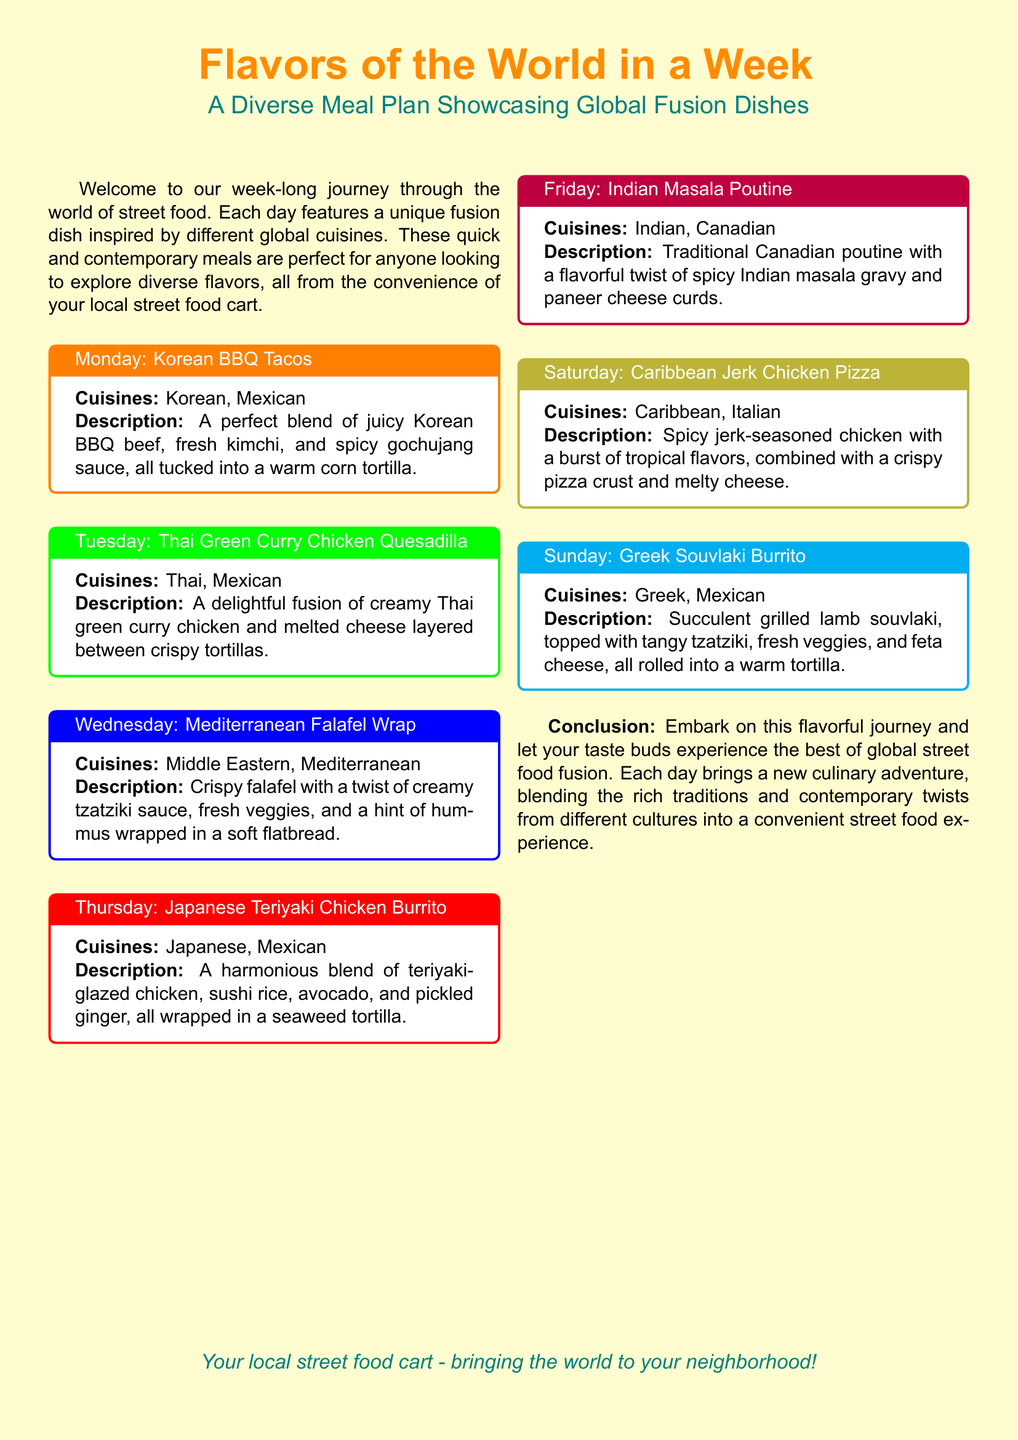What dish is featured on Monday? The dish featured on Monday is Korean BBQ Tacos, outlined in the section designated for that day.
Answer: Korean BBQ Tacos What two cuisines are combined in Tuesday's dish? Tuesday's dish combines Thai and Mexican cuisines, as mentioned in the title of the corresponding section.
Answer: Thai, Mexican What main ingredient is used in Wednesday's Mediterranean dish? The main ingredient in Wednesday's Mediterranean Falafel Wrap, as described, is falafel.
Answer: Falafel Which dish includes paneer cheese curds? The dish that includes paneer cheese curds is Indian Masala Poutine, explicitly mentioned in its description.
Answer: Indian Masala Poutine What day features a burrito with teriyaki chicken? The day featuring a burrito with teriyaki chicken is Thursday, as outlined in the title for that day's dish.
Answer: Thursday How many different cuisines are represented in this meal plan? There are six unique fusion dishes, each highlighting a different pair of cuisines, totaling six distinct cuisines.
Answer: Six What type of food is the focus of this meal plan? The focus of this meal plan is street food, which is noted in both the introduction and conclusion sections.
Answer: Street food Which dish combines Mediterranean flavors with a hint of Middle Eastern? The Mediterranean Falafel Wrap combines those flavors, as identified in the title and description of that day's dish.
Answer: Mediterranean Falafel Wrap What is the theme of this meal plan? The theme of this meal plan is showcasing global fusion dishes, clearly stated in the subtitle.
Answer: Global fusion dishes 